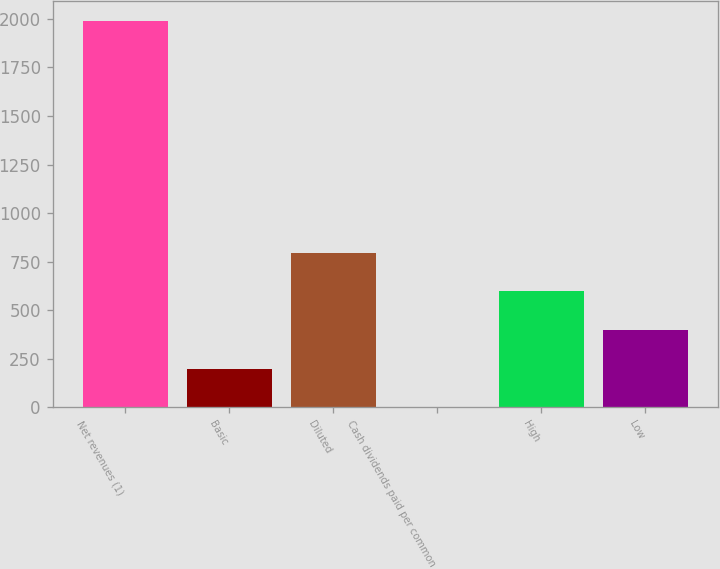Convert chart. <chart><loc_0><loc_0><loc_500><loc_500><bar_chart><fcel>Net revenues (1)<fcel>Basic<fcel>Diluted<fcel>Cash dividends paid per common<fcel>High<fcel>Low<nl><fcel>1990<fcel>199.14<fcel>796.1<fcel>0.15<fcel>597.11<fcel>398.12<nl></chart> 